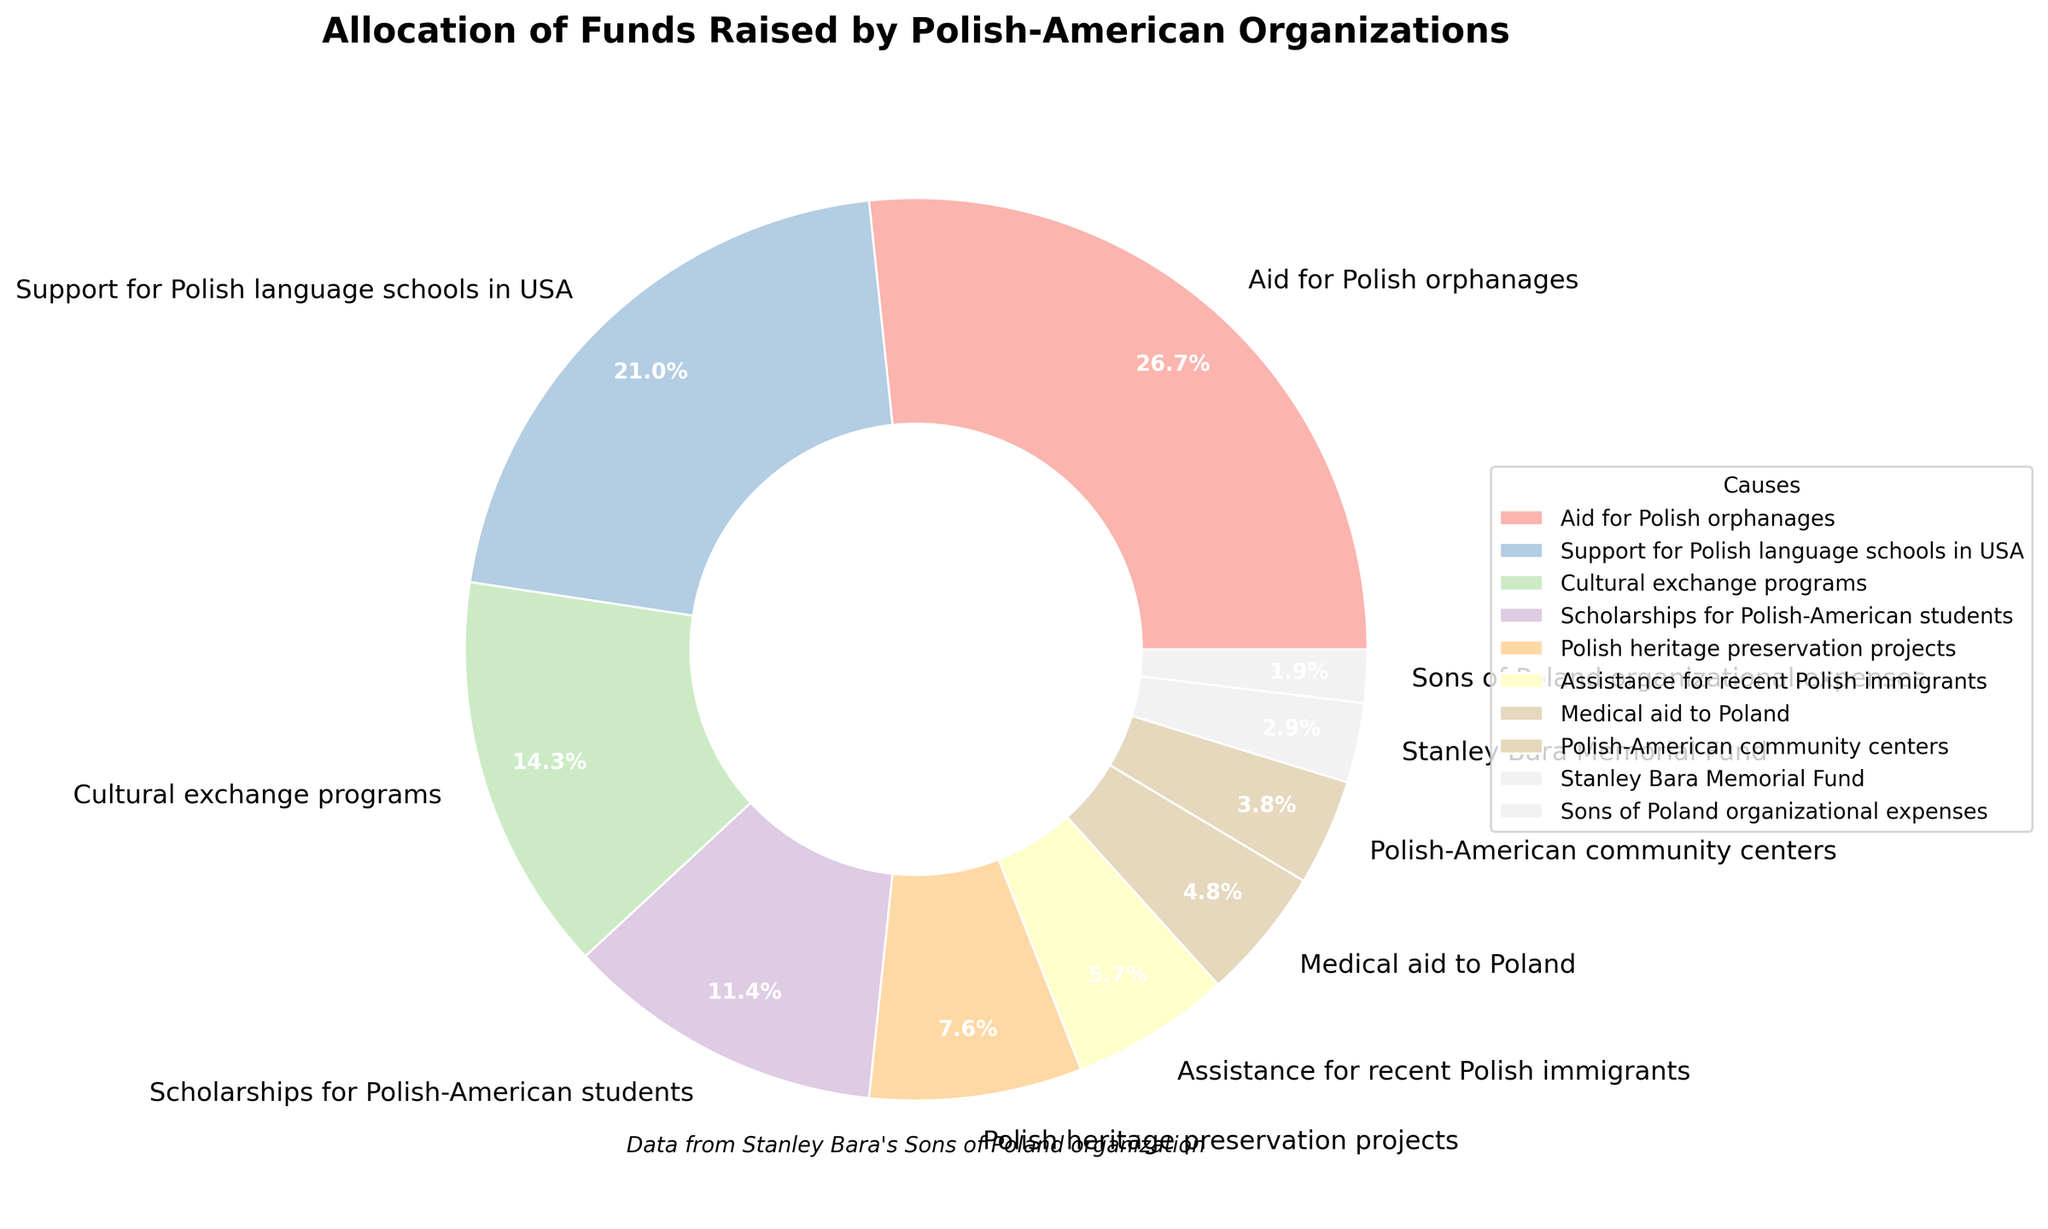What percentage of the funds go towards cultural exchange programs? According to the pie chart, the percentage of funds allocated to cultural exchange programs is clearly labeled.
Answer: 15% Which cause receives the highest percentage of funds? By examining the size of the pie chart segments and checking the labels, the largest segment represents aid for Polish orphanages.
Answer: Aid for Polish orphanages Which cause receives more funding: support for Polish language schools in the USA or assistance for recent Polish immigrants? By comparing the two segments, support for Polish language schools in the USA has a value of 22%, which is greater than the 6% for assistance for recent Polish immigrants.
Answer: Support for Polish language schools in the USA What is the total percentage of funds allocated to scholarships for Polish-American students and Polish heritage preservation projects combined? Adding the percentages for scholarships (12%) and heritage preservation (8%) results in 12% + 8% = 20%.
Answer: 20% How does the funding for the Stanley Bara Memorial Fund compare to the organizational expenses for the Sons of Poland? The chart shows the allocations as 3% for the Stanley Bara Memorial Fund and 2% for the Sons of Poland organizational expenses. 3% is greater than 2%.
Answer: Stanley Bara Memorial Fund is greater What is the difference in percentage between the highest-funded and the lowest-funded causes? The highest-funded cause is aid for Polish orphanages (28%), and the lowest-funded cause is Sons of Poland organizational expenses (2%). The difference is 28% - 2% = 26%.
Answer: 26% Which category receives the least amount of funding, and what is its percentage? The smallest segment on the pie chart is labeled as "Sons of Poland organizational expenses," with 2%.
Answer: Sons of Poland organizational expenses, 2% Is the sum of the percentages for medical aid to Poland and Polish-American community centers greater than the percentage allocated to scholarships for Polish-American students? Adding the percentages of medical aid (5%) and community centers (4%) gives 5% + 4% = 9%, which is less than the 12% allocated to scholarships.
Answer: No Compare the funding percentages between Polish heritage preservation projects and medical aid to Poland. Which receives more? The chart shows that Polish heritage preservation projects receive 8%, while medical aid to Poland receives 5%. 8% is greater than 5%.
Answer: Polish heritage preservation projects How much more funding does support for Polish language schools in the USA receive compared to scholarships for Polish-American students? The figure shows that support for Polish language schools in the USA receives 22%, while scholarships receive 12%. The difference is 22% - 12% = 10%.
Answer: 10% 